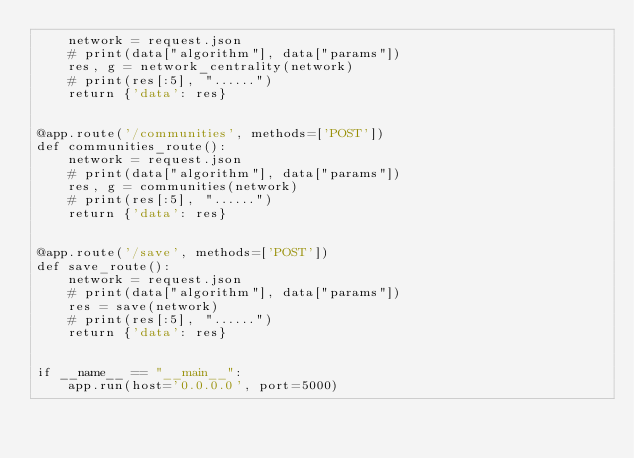Convert code to text. <code><loc_0><loc_0><loc_500><loc_500><_Python_>    network = request.json
    # print(data["algorithm"], data["params"])
    res, g = network_centrality(network)
    # print(res[:5], "......")
    return {'data': res}


@app.route('/communities', methods=['POST'])
def communities_route():
    network = request.json
    # print(data["algorithm"], data["params"])
    res, g = communities(network)
    # print(res[:5], "......")
    return {'data': res}


@app.route('/save', methods=['POST'])
def save_route():
    network = request.json
    # print(data["algorithm"], data["params"])
    res = save(network)
    # print(res[:5], "......")
    return {'data': res}


if __name__ == "__main__":
    app.run(host='0.0.0.0', port=5000)</code> 